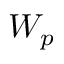<formula> <loc_0><loc_0><loc_500><loc_500>W _ { p }</formula> 